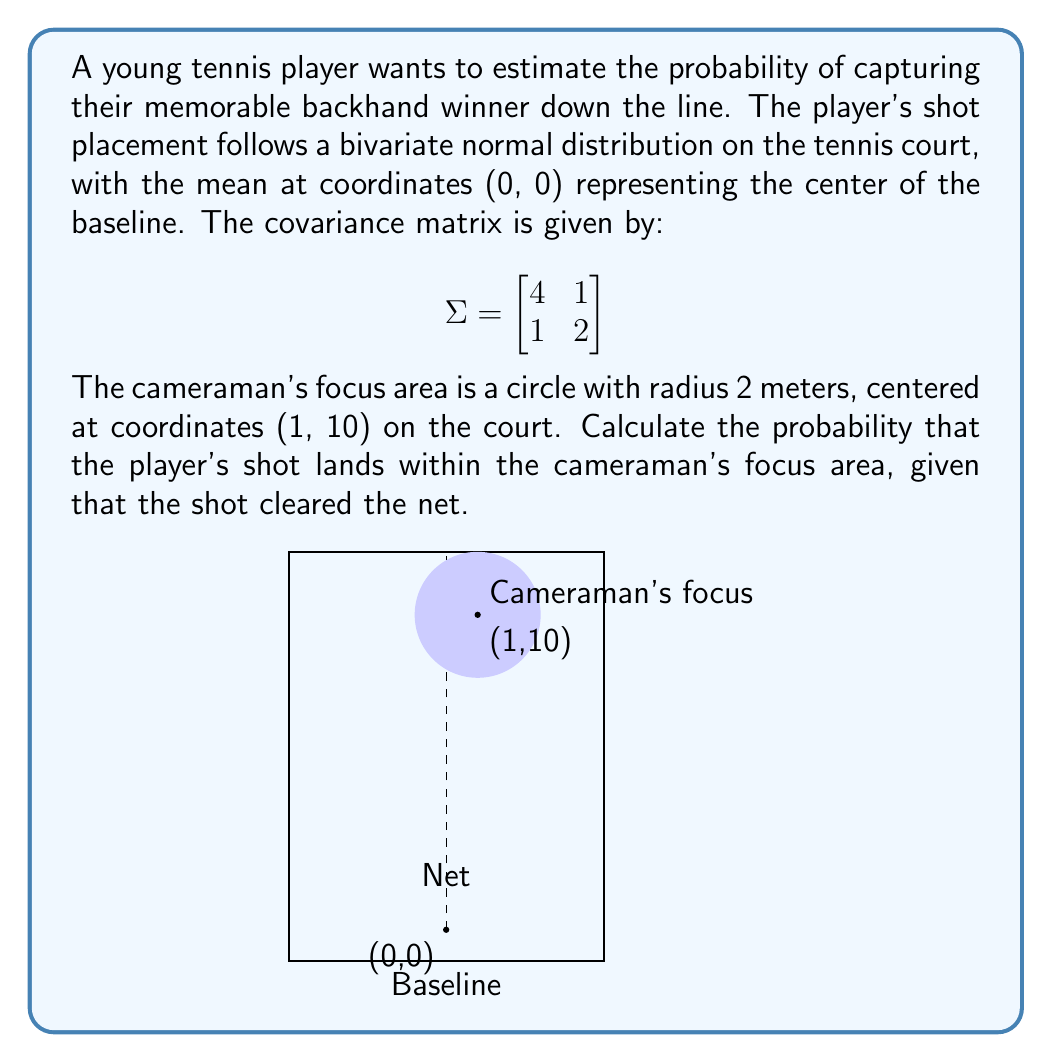Can you solve this math problem? To solve this problem, we'll follow these steps:

1) First, we need to understand that the bivariate normal distribution is given by:

   $$f(x,y) = \frac{1}{2\pi|\Sigma|^{1/2}} \exp\left(-\frac{1}{2}(x-\mu)^T\Sigma^{-1}(x-\mu)\right)$$

   where $\mu = (0,0)$ in this case.

2) The determinant of $\Sigma$ is:
   $$|\Sigma| = 4(2) - 1(1) = 7$$

3) The inverse of $\Sigma$ is:
   $$\Sigma^{-1} = \frac{1}{7}\begin{bmatrix} 
   2 & -1 \\
   -1 & 4
   \end{bmatrix}$$

4) The probability we're looking for is the integral of this distribution over the circular region. However, this is difficult to compute directly.

5) Instead, we can use the cumulative distribution function (CDF) of the bivariate normal distribution, which is implemented in many statistical software packages.

6) The probability that the shot clears the net is approximately 1, as the net is very close to the baseline compared to the standard deviations of the distribution.

7) Therefore, we only need to calculate the probability that the shot lands in the circular region.

8) Using a statistical software package (or a numerical integration method), we can calculate this probability:

   $$P((X-1)^2 + (Y-10)^2 \leq 4) \approx 0.0132$$

9) This means there's about a 1.32% chance that the shot lands in the cameraman's focus area, given that it cleared the net.
Answer: $0.0132$ or $1.32\%$ 